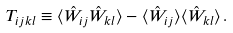Convert formula to latex. <formula><loc_0><loc_0><loc_500><loc_500>T _ { i j k l } \equiv \langle \hat { W } _ { i j } \hat { W } _ { k l } \rangle - \langle \hat { W } _ { i j } \rangle \langle \hat { W } _ { k l } \rangle \, .</formula> 